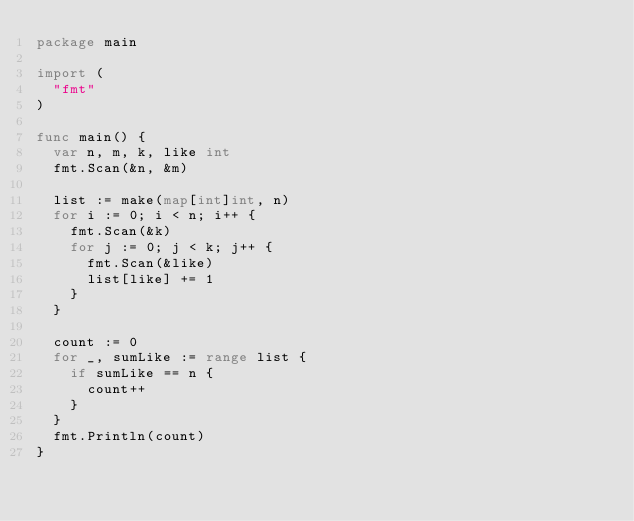<code> <loc_0><loc_0><loc_500><loc_500><_Go_>package main

import (
	"fmt"
)

func main() {
	var n, m, k, like int
	fmt.Scan(&n, &m)

	list := make(map[int]int, n)
	for i := 0; i < n; i++ {
		fmt.Scan(&k)
		for j := 0; j < k; j++ {
			fmt.Scan(&like)
			list[like] += 1
		}
	}

	count := 0
	for _, sumLike := range list {
		if sumLike == n {
			count++
		}
	}
	fmt.Println(count)
}
</code> 